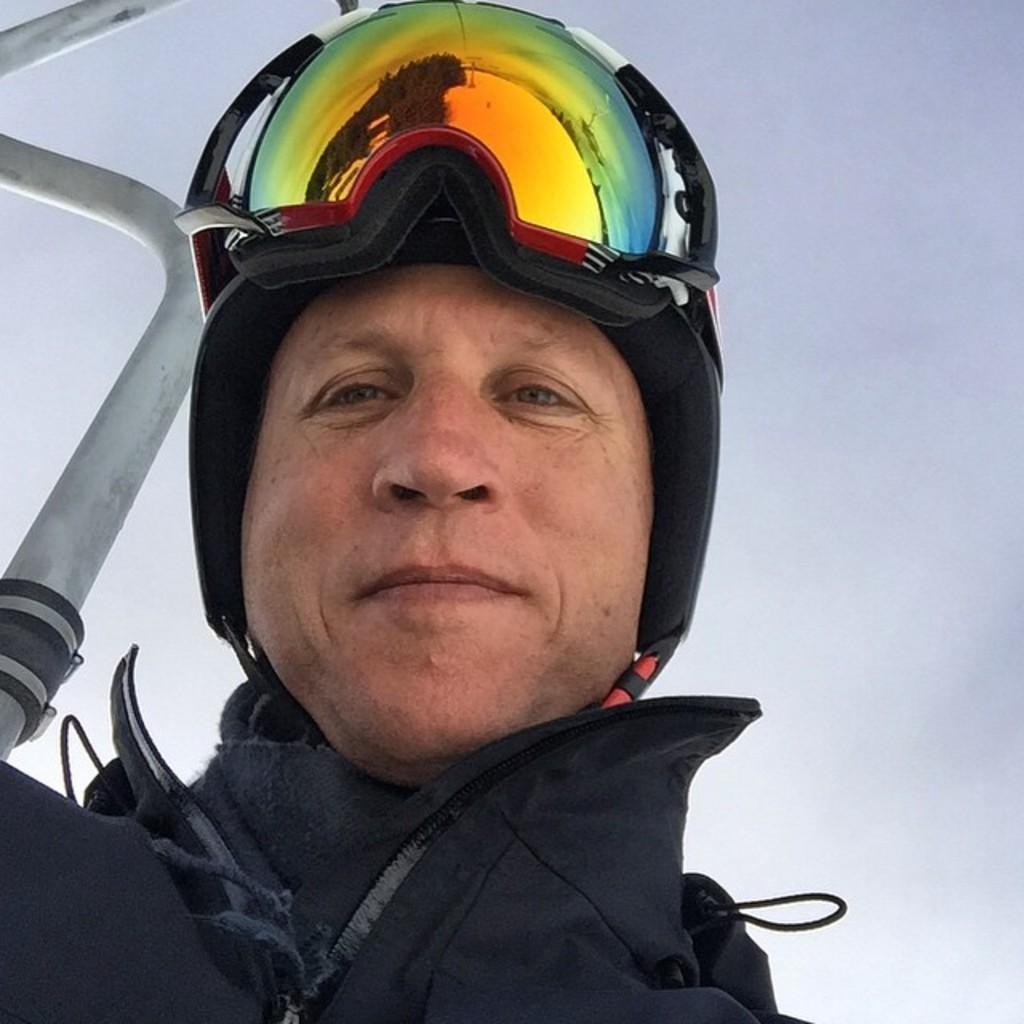Who or what is in the image? There is a person in the image. What can be seen in the background of the image? The background of the image is blue. What is the person wearing? The person is wearing clothes and a helmet. What object can be seen on the left side of the image? There is a metal rod on the left side of the image. What type of apparatus is being used to cover the person in the image? There is no apparatus present in the image that is being used to cover the person. 